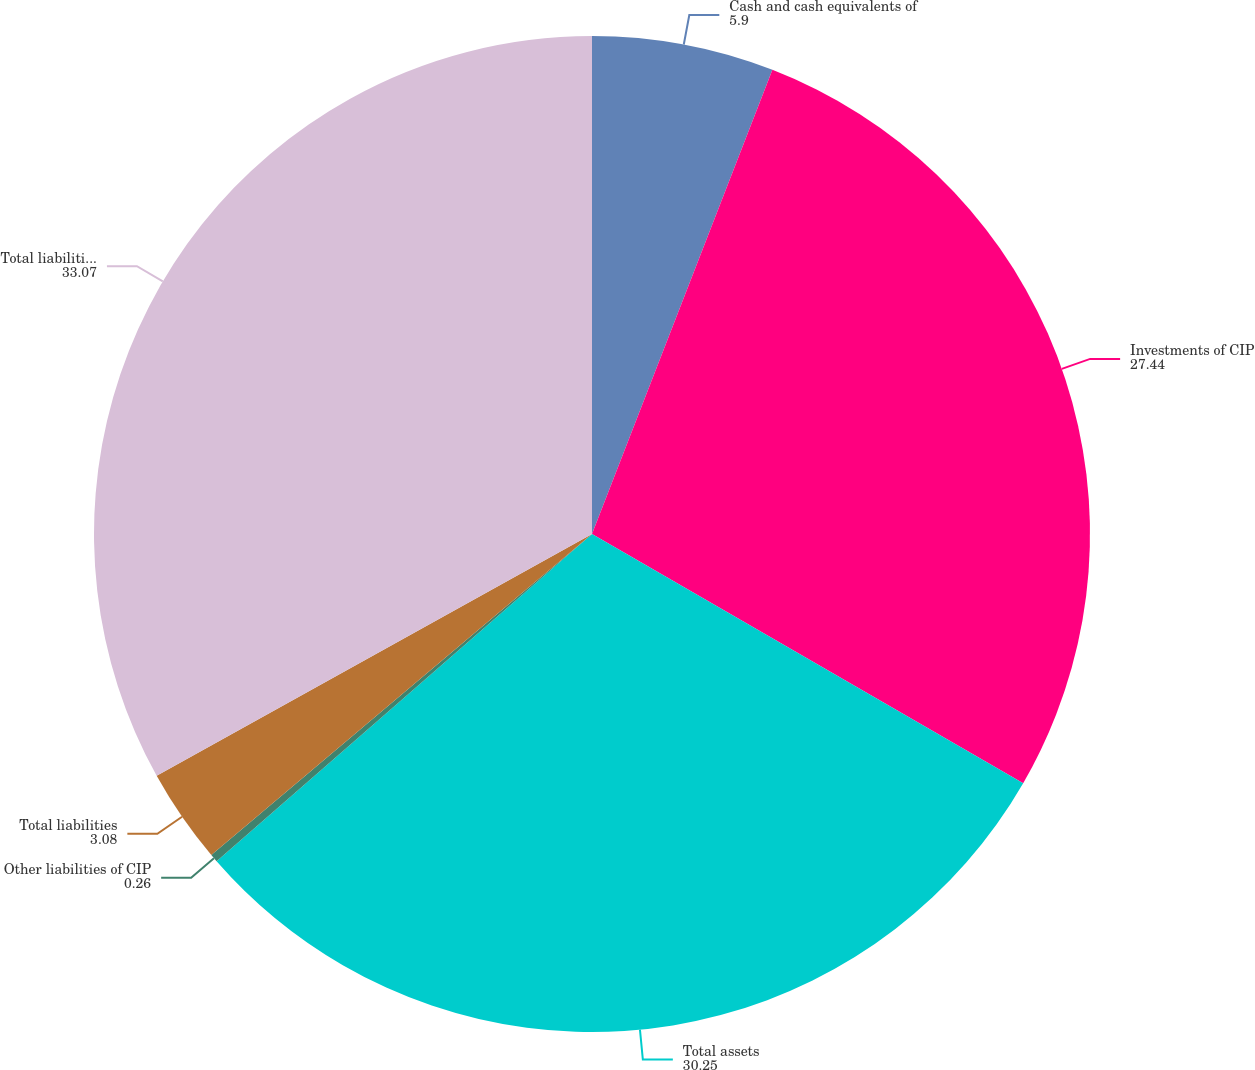<chart> <loc_0><loc_0><loc_500><loc_500><pie_chart><fcel>Cash and cash equivalents of<fcel>Investments of CIP<fcel>Total assets<fcel>Other liabilities of CIP<fcel>Total liabilities<fcel>Total liabilities and equity<nl><fcel>5.9%<fcel>27.44%<fcel>30.25%<fcel>0.26%<fcel>3.08%<fcel>33.07%<nl></chart> 